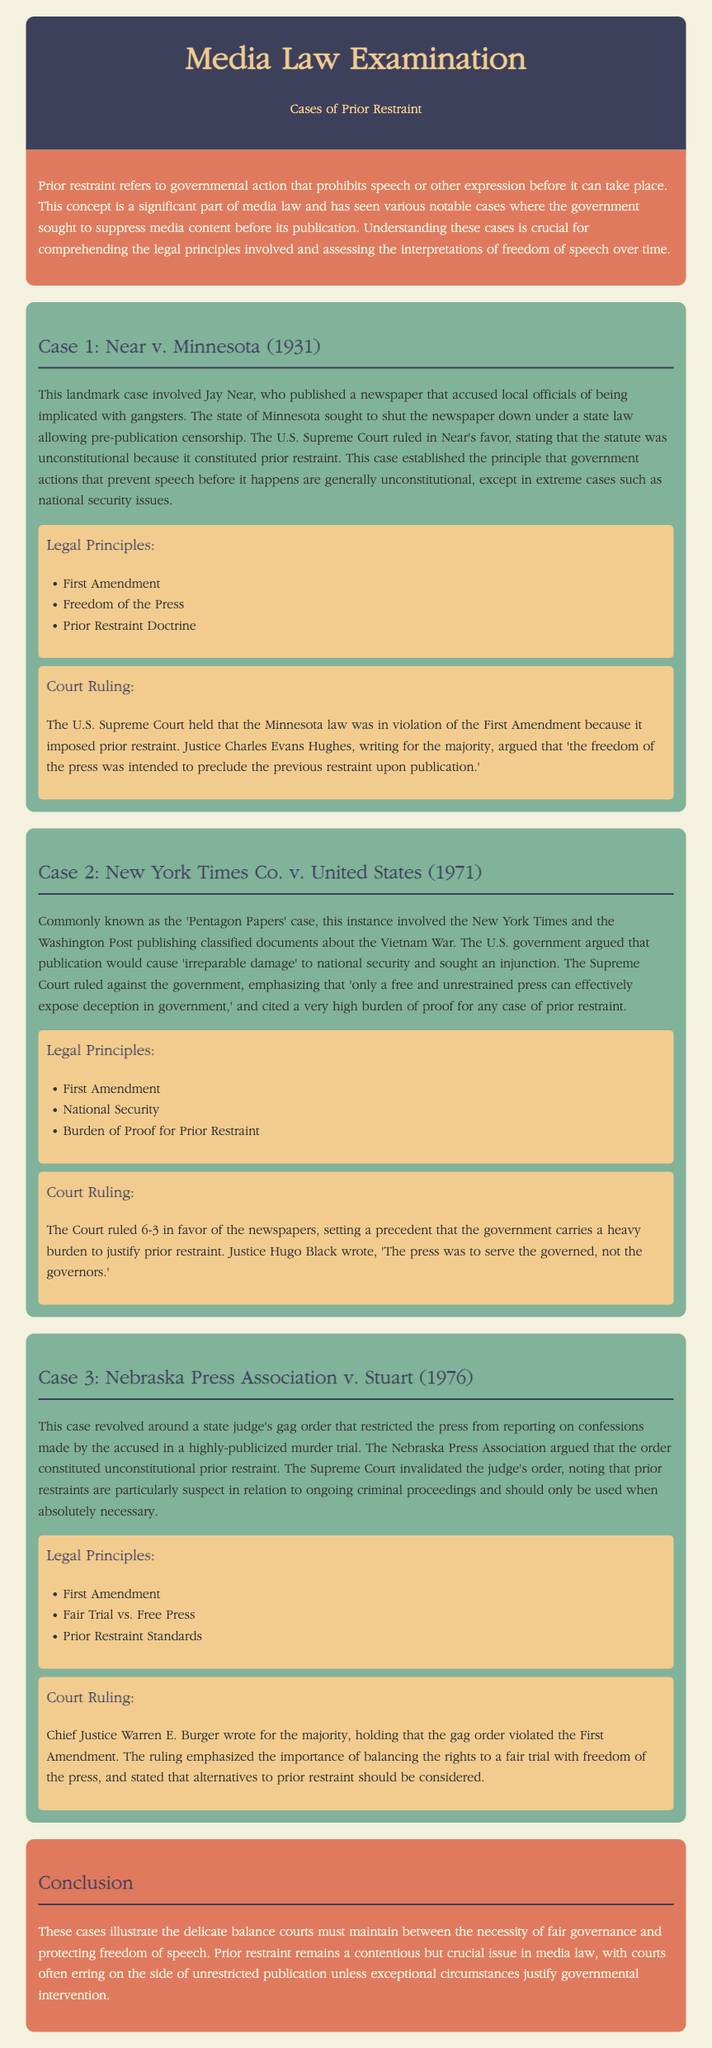What is the first case discussed in the document? The first case mentioned is "Near v. Minnesota."
Answer: Near v. Minnesota In what year was the case Near v. Minnesota decided? The case was decided in 1931.
Answer: 1931 What was the government’s argument in New York Times Co. v. United States? The government claimed that publication would cause "irreparable damage" to national security.
Answer: irreparable damage What principle did the Supreme Court emphasize regarding prior restraint in New York Times Co. v. United States? The Court stated that the government carries a heavy burden to justify prior restraint.
Answer: heavy burden Who wrote the majority opinion in the case Nebraska Press Association v. Stuart? Chief Justice Warren E. Burger wrote the majority opinion.
Answer: Warren E. Burger What is the main topic of the document? The document focuses on cases of prior restraint in media law.
Answer: cases of prior restraint What is the conclusion of the document about prior restraint? The conclusion states that courts often err on the side of unrestricted publication.
Answer: unrestricted publication What type of law does the document primarily discuss? The document primarily discusses media law.
Answer: media law What legal principle is a common theme across all the discussed cases? The First Amendment is a common legal principle in all cases.
Answer: First Amendment 